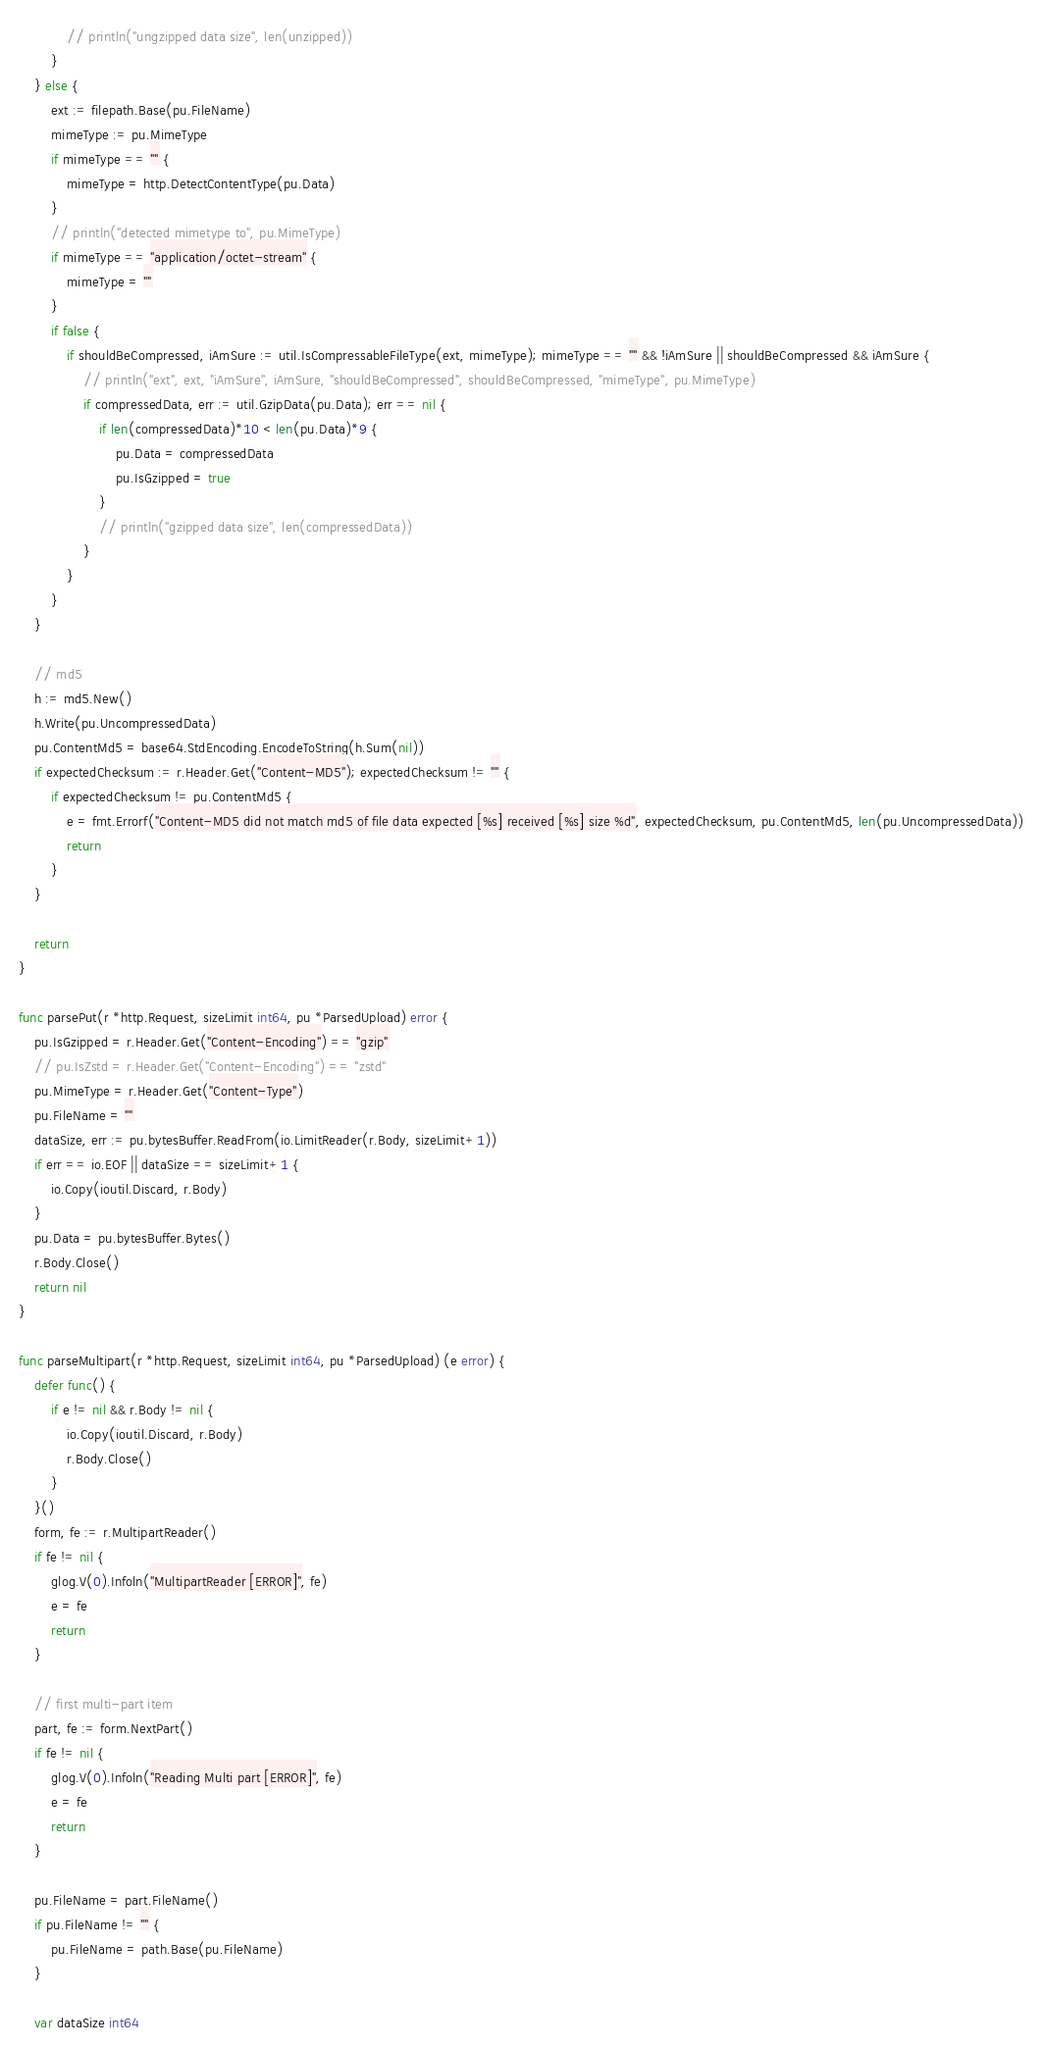<code> <loc_0><loc_0><loc_500><loc_500><_Go_>			// println("ungzipped data size", len(unzipped))
		}
	} else {
		ext := filepath.Base(pu.FileName)
		mimeType := pu.MimeType
		if mimeType == "" {
			mimeType = http.DetectContentType(pu.Data)
		}
		// println("detected mimetype to", pu.MimeType)
		if mimeType == "application/octet-stream" {
			mimeType = ""
		}
		if false {
			if shouldBeCompressed, iAmSure := util.IsCompressableFileType(ext, mimeType); mimeType == "" && !iAmSure || shouldBeCompressed && iAmSure {
				// println("ext", ext, "iAmSure", iAmSure, "shouldBeCompressed", shouldBeCompressed, "mimeType", pu.MimeType)
				if compressedData, err := util.GzipData(pu.Data); err == nil {
					if len(compressedData)*10 < len(pu.Data)*9 {
						pu.Data = compressedData
						pu.IsGzipped = true
					}
					// println("gzipped data size", len(compressedData))
				}
			}
		}
	}

	// md5
	h := md5.New()
	h.Write(pu.UncompressedData)
	pu.ContentMd5 = base64.StdEncoding.EncodeToString(h.Sum(nil))
	if expectedChecksum := r.Header.Get("Content-MD5"); expectedChecksum != "" {
		if expectedChecksum != pu.ContentMd5 {
			e = fmt.Errorf("Content-MD5 did not match md5 of file data expected [%s] received [%s] size %d", expectedChecksum, pu.ContentMd5, len(pu.UncompressedData))
			return
		}
	}

	return
}

func parsePut(r *http.Request, sizeLimit int64, pu *ParsedUpload) error {
	pu.IsGzipped = r.Header.Get("Content-Encoding") == "gzip"
	// pu.IsZstd = r.Header.Get("Content-Encoding") == "zstd"
	pu.MimeType = r.Header.Get("Content-Type")
	pu.FileName = ""
	dataSize, err := pu.bytesBuffer.ReadFrom(io.LimitReader(r.Body, sizeLimit+1))
	if err == io.EOF || dataSize == sizeLimit+1 {
		io.Copy(ioutil.Discard, r.Body)
	}
	pu.Data = pu.bytesBuffer.Bytes()
	r.Body.Close()
	return nil
}

func parseMultipart(r *http.Request, sizeLimit int64, pu *ParsedUpload) (e error) {
	defer func() {
		if e != nil && r.Body != nil {
			io.Copy(ioutil.Discard, r.Body)
			r.Body.Close()
		}
	}()
	form, fe := r.MultipartReader()
	if fe != nil {
		glog.V(0).Infoln("MultipartReader [ERROR]", fe)
		e = fe
		return
	}

	// first multi-part item
	part, fe := form.NextPart()
	if fe != nil {
		glog.V(0).Infoln("Reading Multi part [ERROR]", fe)
		e = fe
		return
	}

	pu.FileName = part.FileName()
	if pu.FileName != "" {
		pu.FileName = path.Base(pu.FileName)
	}

	var dataSize int64</code> 